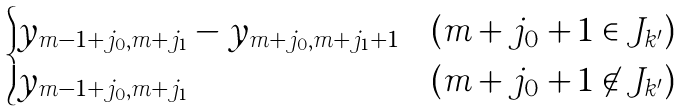<formula> <loc_0><loc_0><loc_500><loc_500>\begin{cases} y _ { m - 1 + j _ { 0 } , m + j _ { 1 } } - y _ { m + j _ { 0 } , m + j _ { 1 } + 1 } & ( m + j _ { 0 } + 1 \in J _ { k ^ { \prime } } ) \\ y _ { m - 1 + j _ { 0 } , m + j _ { 1 } } & ( m + j _ { 0 } + 1 \not \in J _ { k ^ { \prime } } ) \end{cases}</formula> 